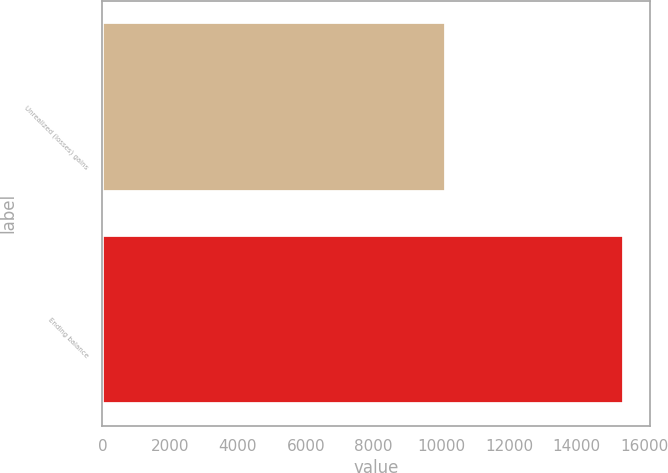Convert chart. <chart><loc_0><loc_0><loc_500><loc_500><bar_chart><fcel>Unrealized (losses) gains<fcel>Ending balance<nl><fcel>10154<fcel>15402<nl></chart> 